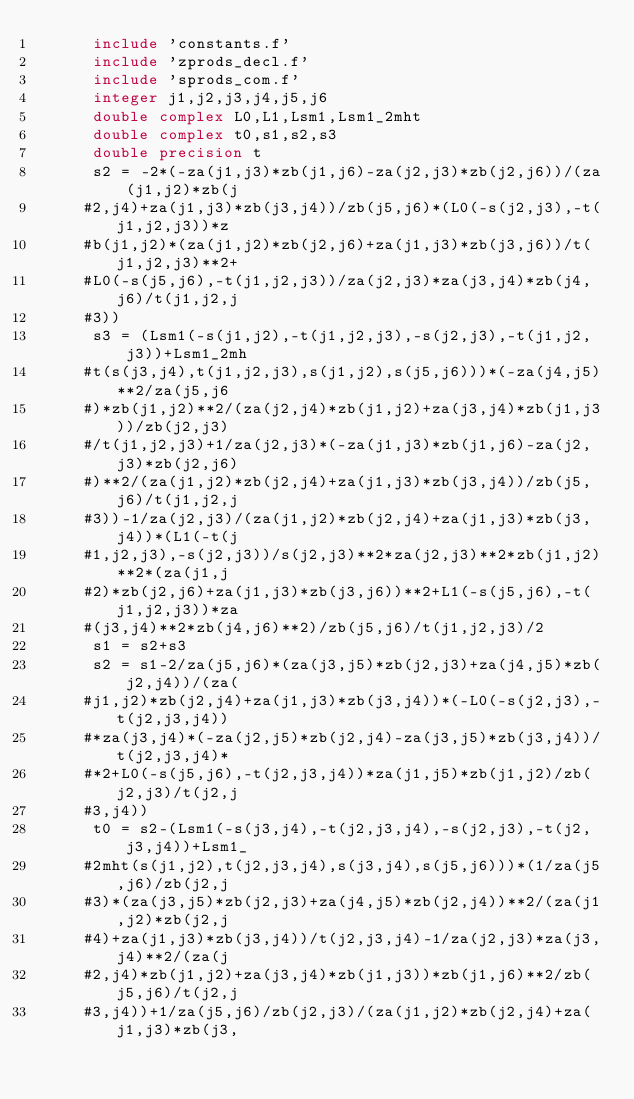<code> <loc_0><loc_0><loc_500><loc_500><_FORTRAN_>      include 'constants.f'
      include 'zprods_decl.f'
      include 'sprods_com.f'
      integer j1,j2,j3,j4,j5,j6
      double complex L0,L1,Lsm1,Lsm1_2mht
      double complex t0,s1,s2,s3
      double precision t
      s2 = -2*(-za(j1,j3)*zb(j1,j6)-za(j2,j3)*zb(j2,j6))/(za(j1,j2)*zb(j
     #2,j4)+za(j1,j3)*zb(j3,j4))/zb(j5,j6)*(L0(-s(j2,j3),-t(j1,j2,j3))*z
     #b(j1,j2)*(za(j1,j2)*zb(j2,j6)+za(j1,j3)*zb(j3,j6))/t(j1,j2,j3)**2+
     #L0(-s(j5,j6),-t(j1,j2,j3))/za(j2,j3)*za(j3,j4)*zb(j4,j6)/t(j1,j2,j
     #3))
      s3 = (Lsm1(-s(j1,j2),-t(j1,j2,j3),-s(j2,j3),-t(j1,j2,j3))+Lsm1_2mh
     #t(s(j3,j4),t(j1,j2,j3),s(j1,j2),s(j5,j6)))*(-za(j4,j5)**2/za(j5,j6
     #)*zb(j1,j2)**2/(za(j2,j4)*zb(j1,j2)+za(j3,j4)*zb(j1,j3))/zb(j2,j3)
     #/t(j1,j2,j3)+1/za(j2,j3)*(-za(j1,j3)*zb(j1,j6)-za(j2,j3)*zb(j2,j6)
     #)**2/(za(j1,j2)*zb(j2,j4)+za(j1,j3)*zb(j3,j4))/zb(j5,j6)/t(j1,j2,j
     #3))-1/za(j2,j3)/(za(j1,j2)*zb(j2,j4)+za(j1,j3)*zb(j3,j4))*(L1(-t(j
     #1,j2,j3),-s(j2,j3))/s(j2,j3)**2*za(j2,j3)**2*zb(j1,j2)**2*(za(j1,j
     #2)*zb(j2,j6)+za(j1,j3)*zb(j3,j6))**2+L1(-s(j5,j6),-t(j1,j2,j3))*za
     #(j3,j4)**2*zb(j4,j6)**2)/zb(j5,j6)/t(j1,j2,j3)/2
      s1 = s2+s3
      s2 = s1-2/za(j5,j6)*(za(j3,j5)*zb(j2,j3)+za(j4,j5)*zb(j2,j4))/(za(
     #j1,j2)*zb(j2,j4)+za(j1,j3)*zb(j3,j4))*(-L0(-s(j2,j3),-t(j2,j3,j4))
     #*za(j3,j4)*(-za(j2,j5)*zb(j2,j4)-za(j3,j5)*zb(j3,j4))/t(j2,j3,j4)*
     #*2+L0(-s(j5,j6),-t(j2,j3,j4))*za(j1,j5)*zb(j1,j2)/zb(j2,j3)/t(j2,j
     #3,j4))
      t0 = s2-(Lsm1(-s(j3,j4),-t(j2,j3,j4),-s(j2,j3),-t(j2,j3,j4))+Lsm1_
     #2mht(s(j1,j2),t(j2,j3,j4),s(j3,j4),s(j5,j6)))*(1/za(j5,j6)/zb(j2,j
     #3)*(za(j3,j5)*zb(j2,j3)+za(j4,j5)*zb(j2,j4))**2/(za(j1,j2)*zb(j2,j
     #4)+za(j1,j3)*zb(j3,j4))/t(j2,j3,j4)-1/za(j2,j3)*za(j3,j4)**2/(za(j
     #2,j4)*zb(j1,j2)+za(j3,j4)*zb(j1,j3))*zb(j1,j6)**2/zb(j5,j6)/t(j2,j
     #3,j4))+1/za(j5,j6)/zb(j2,j3)/(za(j1,j2)*zb(j2,j4)+za(j1,j3)*zb(j3,</code> 